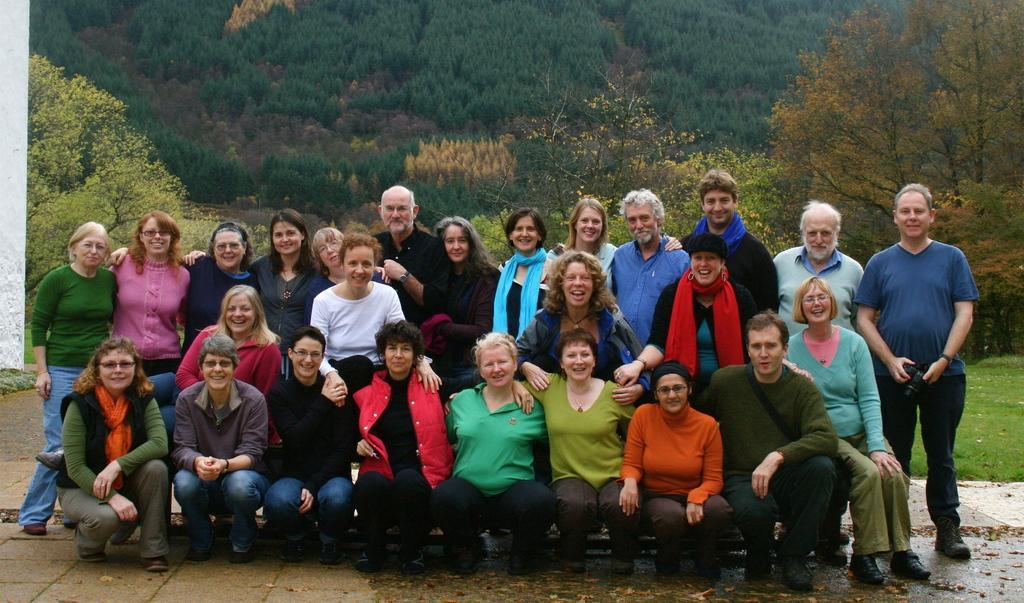Can you describe this image briefly? In this picture there are group of people where few among them are crouching and the remaining are standing behind them and there are trees in the background. 